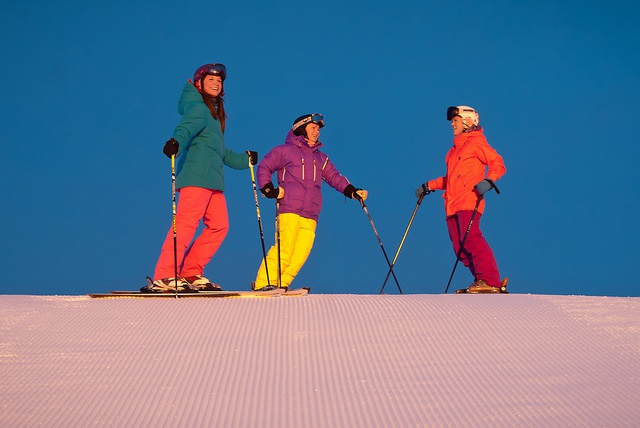Describe the objects in this image and their specific colors. I can see people in blue, teal, and red tones, people in blue, purple, gold, and black tones, people in blue, red, brown, and teal tones, and skis in blue, maroon, tan, and brown tones in this image. 